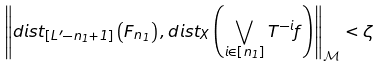<formula> <loc_0><loc_0><loc_500><loc_500>\left \| d i s t _ { \left [ L ^ { \prime } - n _ { 1 } + 1 \right ] } \left ( F _ { n _ { 1 } } \right ) , d i s t _ { X } \left ( \bigvee _ { i \in \left [ n _ { 1 } \right ] } T ^ { - i } f \right ) \right \| _ { \mathcal { M } } < \zeta</formula> 